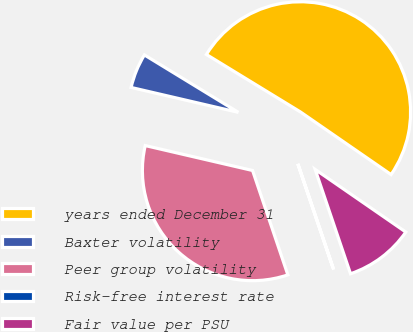Convert chart. <chart><loc_0><loc_0><loc_500><loc_500><pie_chart><fcel>years ended December 31<fcel>Baxter volatility<fcel>Peer group volatility<fcel>Risk-free interest rate<fcel>Fair value per PSU<nl><fcel>50.89%<fcel>5.1%<fcel>33.82%<fcel>0.01%<fcel>10.18%<nl></chart> 